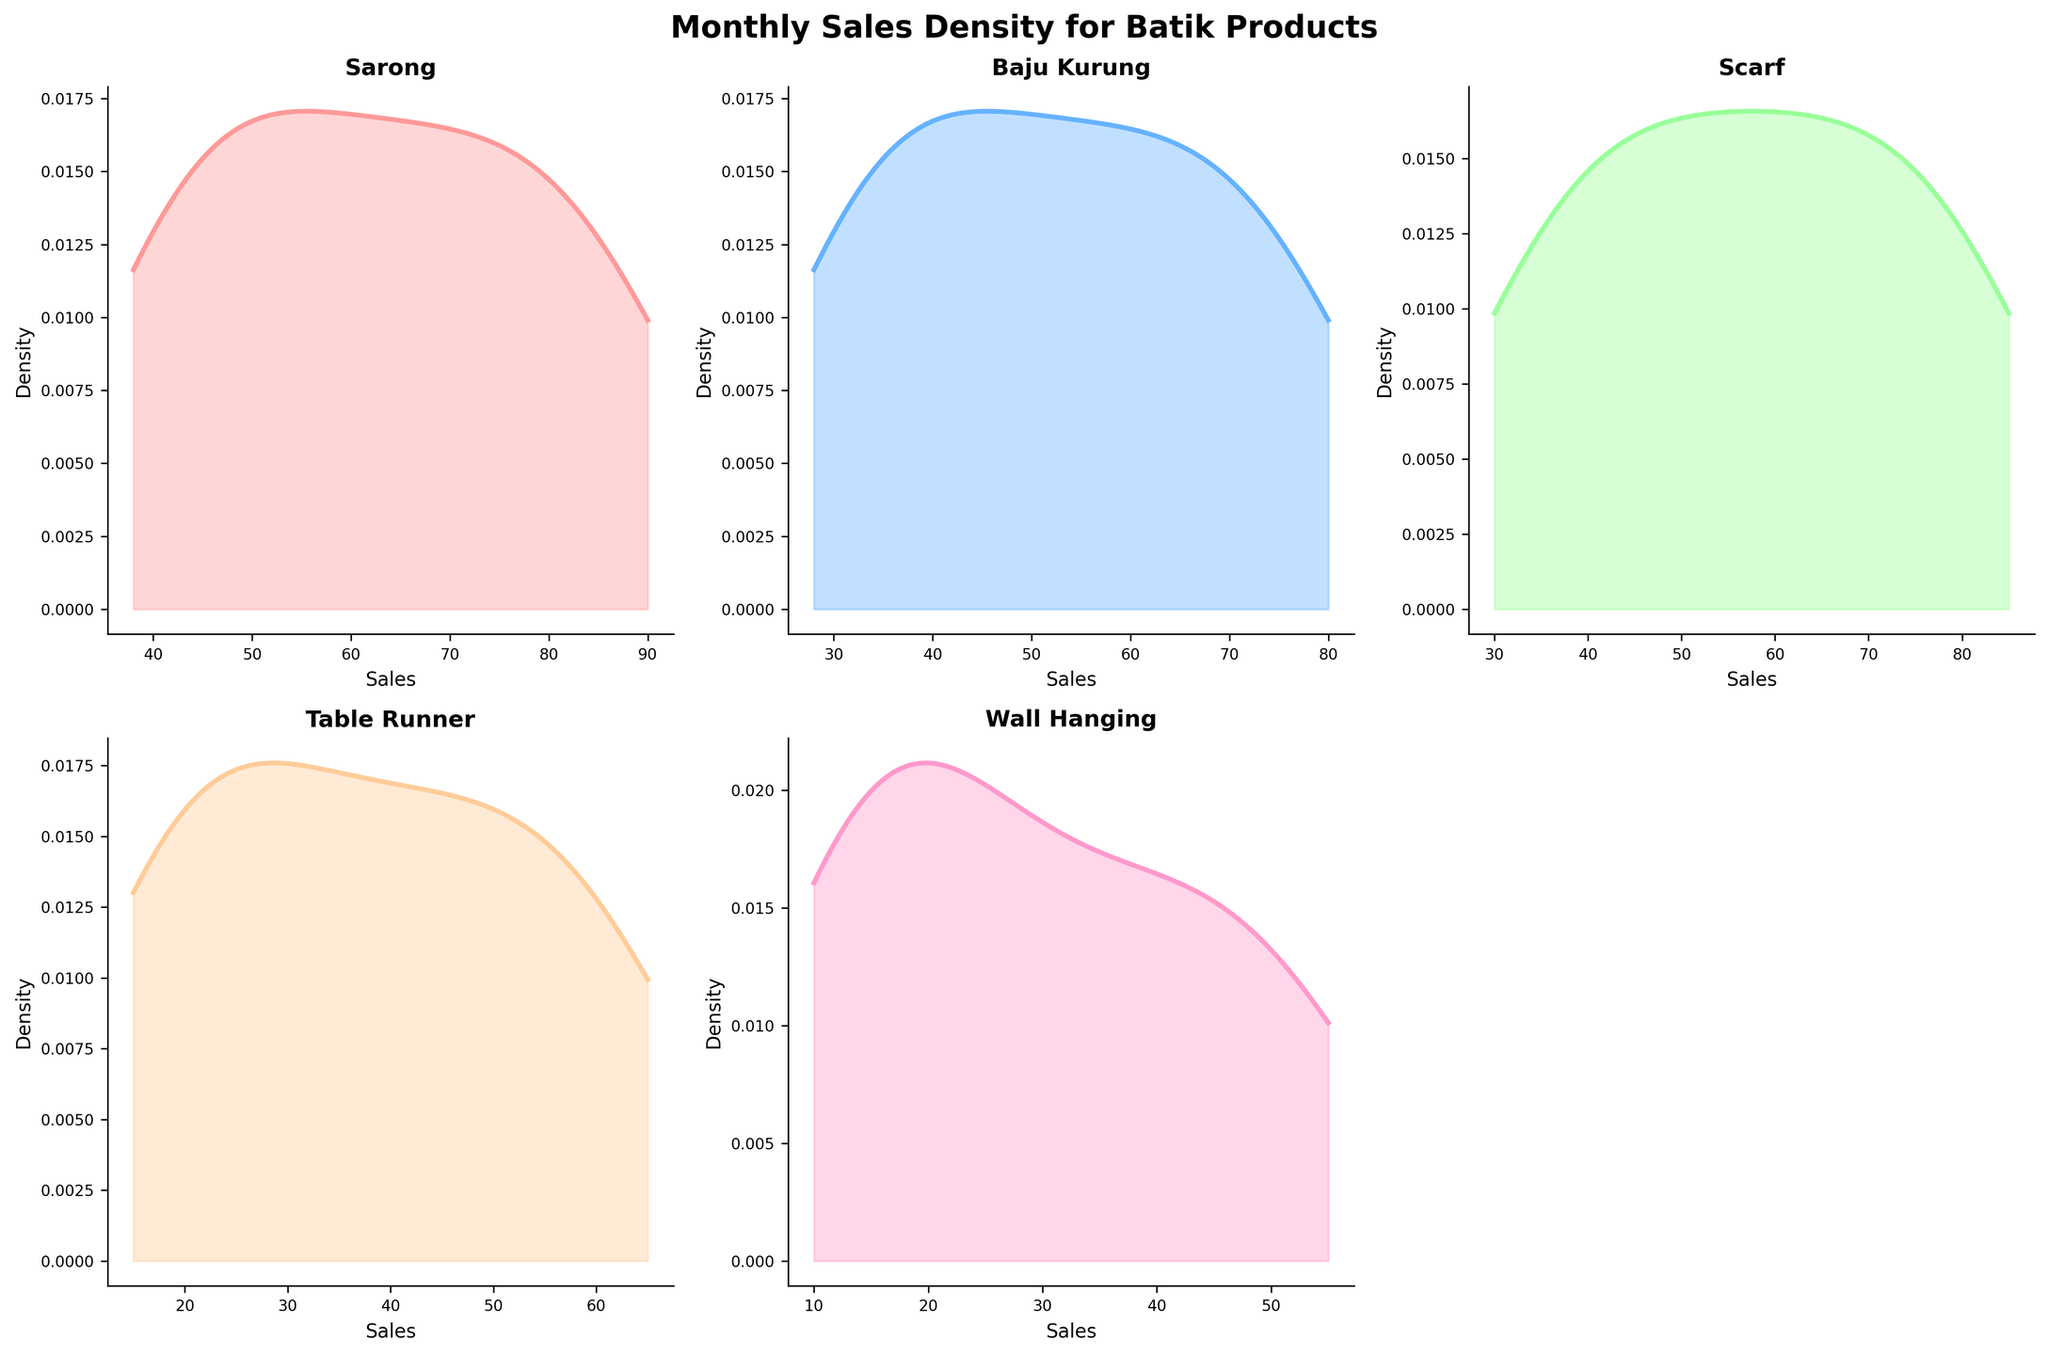How many batik product categories are shown in the figure? The figure consists of subplots for each batik product category. We can count the tiles to determine the number of categories included.
Answer: 5 Which category shows the highest density peak? To determine this, we need to look for the highest point on the density curves across all subplots.
Answer: Sarong At what sales value does the Sarong category show its highest density? To answer this, we need to find the x-coordinate where the Sarong density curve reaches its highest point.
Answer: Approximately 90 Do all categories follow a similar trend in their sales pattern? We need to observe and compare the overall shape of all density curves to determine if they exhibit a similar trend.
Answer: Yes Is the sales density of 'Wall Hanging' more evenly spread than 'Baju Kurung'? Compare the width and height of the density curves for both categories. A more evenly spread distribution will have a wider and flatter density.
Answer: Yes What's the range of sales values plotted for the 'Table Runner' category? To determine the range, identify the minimum and maximum sales values shown on the x-axis for the Table Runner subplot.
Answer: 15 to 65 Between 'Scarf' and 'Wall Hanging', which category shows a steeper increase in density at low sales values? We need to observe the initial steepness of the density curves at the left side of the plots for both categories.
Answer: Scarf Which category has its density curve most skewed towards higher sales values? We can identify this by finding the category whose curve peaks closer to the higher end (right side) of the sales values.
Answer: Sarong Are there any categories whose density curves have multiple peaks? Look for additional peaks in any of the density plots.
Answer: No Which category follows a similar sales density pattern to 'Baju Kurung'? Look for a subplot whose density curve shape closely resembles that of the 'Baju Kurung'.
Answer: Scarf 